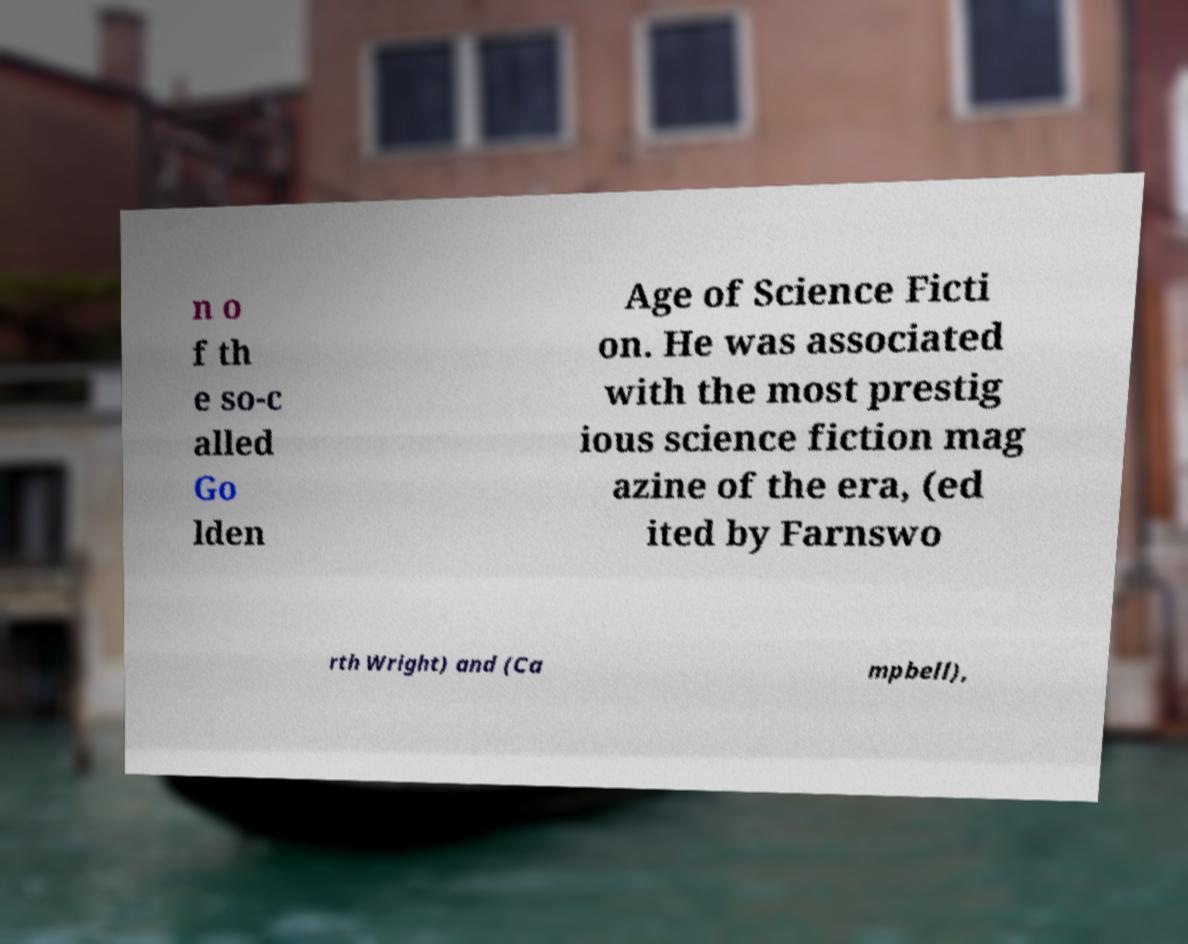Can you read and provide the text displayed in the image?This photo seems to have some interesting text. Can you extract and type it out for me? n o f th e so-c alled Go lden Age of Science Ficti on. He was associated with the most prestig ious science fiction mag azine of the era, (ed ited by Farnswo rth Wright) and (Ca mpbell), 